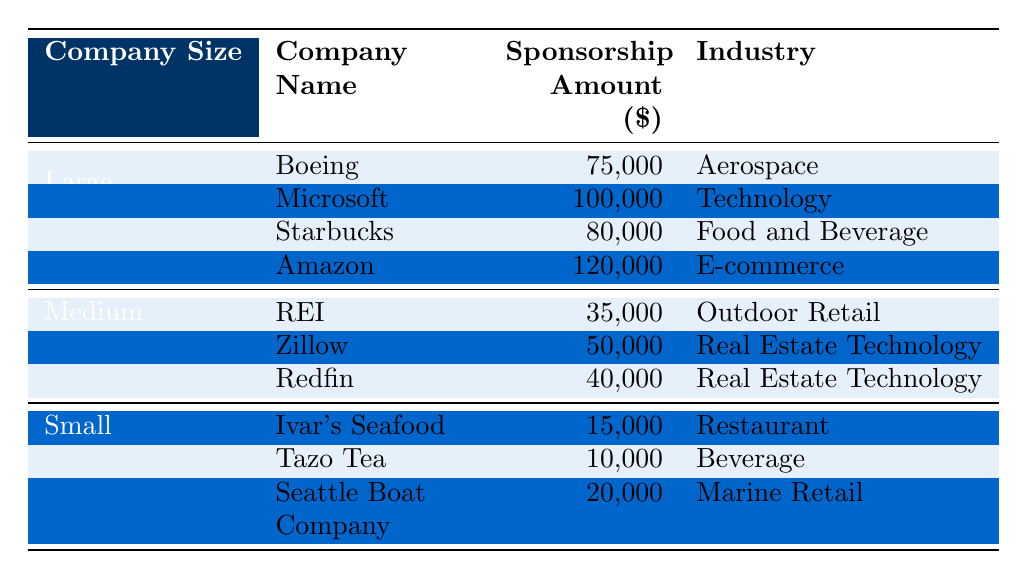What is the total sponsorship amount from large companies? The table lists four large companies with their respective sponsorship amounts: Boeing ($75,000), Microsoft ($100,000), Starbucks ($80,000), and Amazon ($120,000). By summing these amounts, we get: 75,000 + 100,000 + 80,000 + 120,000 = 375,000.
Answer: 375,000 Which small company provided the highest sponsorship amount? The table shows three small companies with their sponsorship amounts: Ivar's Seafood ($15,000), Tazo Tea ($10,000), and Seattle Boat Company ($20,000). Comparing these values, Seattle Boat Company has the highest amount.
Answer: Seattle Boat Company Is there any company in the table from the Aerospace industry? Yes, the table lists Boeing as a large company in the Aerospace industry.
Answer: Yes What is the average sponsorship amount for medium-sized companies? There are three medium-sized companies with their sponsorship amounts: REI ($35,000), Zillow ($50,000), and Redfin ($40,000). The total sponsorship amount is 35,000 + 50,000 + 40,000 = 125,000. The average is calculated by dividing this total by the number of companies (3), resulting in 125,000 / 3 = approximately 41,667.
Answer: 41,667 How much more did Amazon contribute compared to Boeing? Amazon's sponsorship amount is $120,000, and Boeing's is $75,000. To find the difference, we subtract Boeing's amount from Amazon's: 120,000 - 75,000 = 45,000.
Answer: 45,000 Which industry attracted the highest sponsorship from large companies? The table shows that among large companies, the amounts in the respective industries are: Aerospace (75,000), Technology (100,000), Food and Beverage (80,000), and E-commerce (120,000). The highest amount is from the E-commerce industry (Amazon).
Answer: E-commerce What is the total number of sponsorship amounts listed for small companies? The table includes three small companies: Ivar's Seafood ($15,000), Tazo Tea ($10,000), and Seattle Boat Company ($20,000). This means there are three distinct amounts listed for small companies.
Answer: 3 Which company contributed the least amount in sponsorship among all listed? Looking at the sponsorship amounts in the table, Tazo Tea has the least at $10,000, which is lower than Ivar's Seafood ($15,000) and Seattle Boat Company ($20,000).
Answer: Tazo Tea What percentage of the total sponsorship amount for medium companies does Zillow represent? The total for medium companies is $35,000 + $50,000 + $40,000 = $125,000. Zillow contributed $50,000. To compute the percentage: (50,000 / 125,000) * 100 = 40%.
Answer: 40% How many companies contributed more than $50,000 in sponsorship? The table lists Microsoft ($100,000), Starbucks ($80,000), and Amazon ($120,000) as having contributed amounts over $50,000. Therefore, three companies meet this criterion.
Answer: 3 What is the total sponsorship from all companies listed in the table? Summing all the sponsorship amounts: 75,000 + 100,000 + 80,000 + 120,000 + 35,000 + 50,000 + 40,000 + 15,000 + 10,000 + 20,000 gives a total of 525,000.
Answer: 525,000 